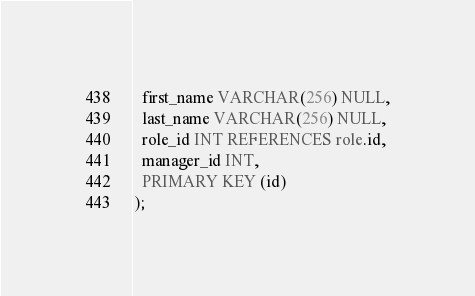<code> <loc_0><loc_0><loc_500><loc_500><_SQL_>  first_name VARCHAR(256) NULL,
  last_name VARCHAR(256) NULL,
  role_id INT REFERENCES role.id,
  manager_id INT,
  PRIMARY KEY (id)
);</code> 